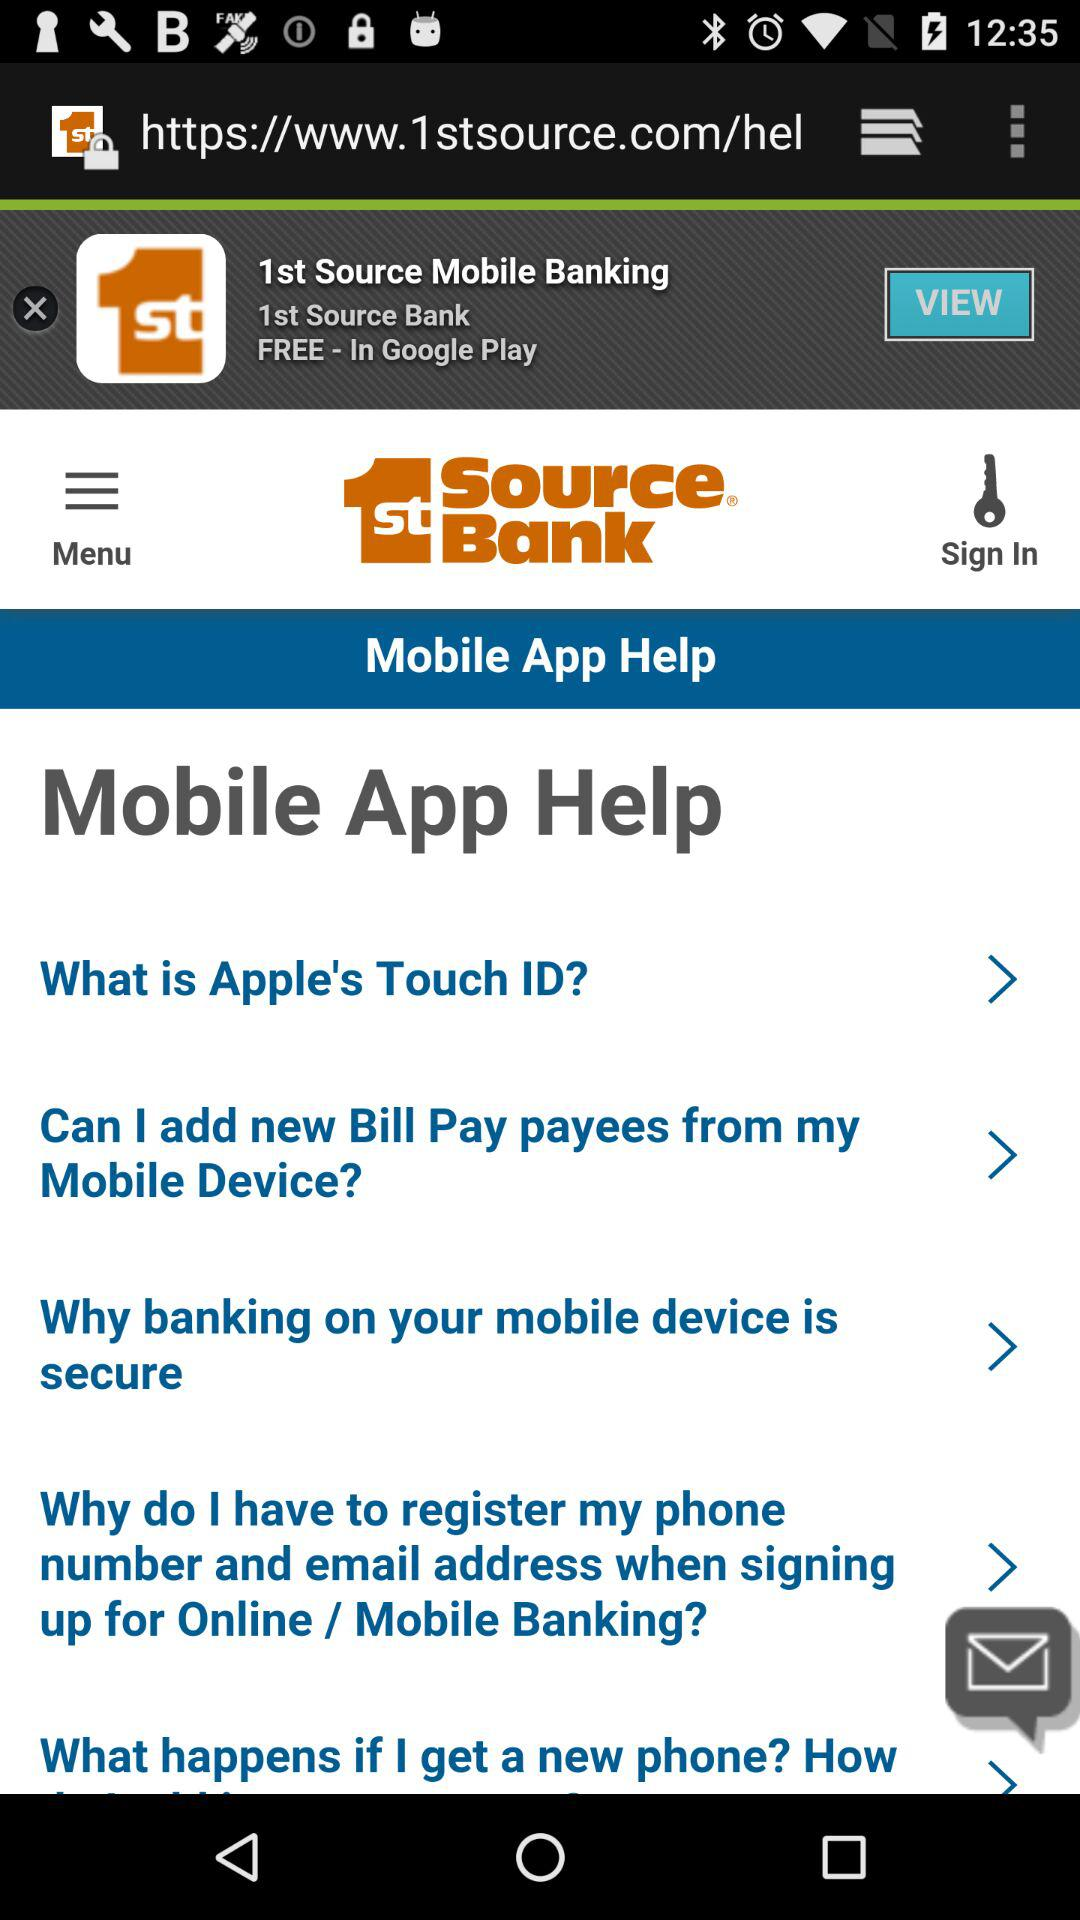What is the name of the application? The name of the application is "1st Source Bank". 